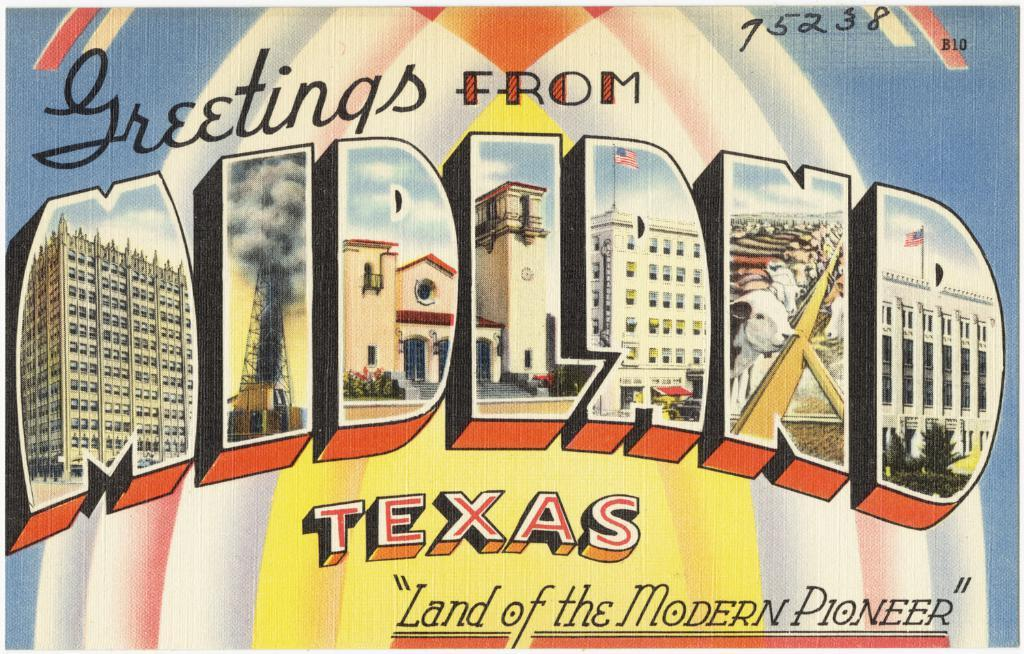<image>
Render a clear and concise summary of the photo. Midland, Texas is also known as the land of the modern pioneer 